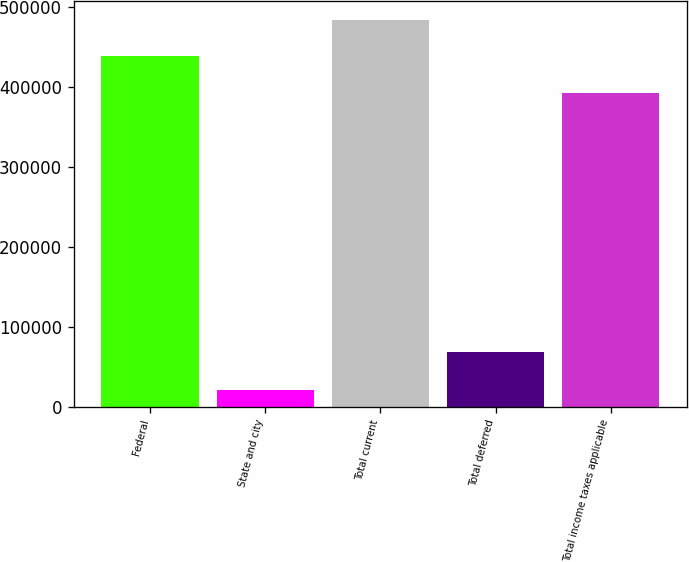Convert chart. <chart><loc_0><loc_0><loc_500><loc_500><bar_chart><fcel>Federal<fcel>State and city<fcel>Total current<fcel>Total deferred<fcel>Total income taxes applicable<nl><fcel>439632<fcel>21070<fcel>483595<fcel>68249<fcel>392453<nl></chart> 